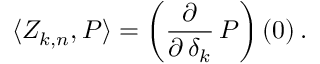<formula> <loc_0><loc_0><loc_500><loc_500>\langle Z _ { k , n } , P \rangle = \left ( { \frac { \partial } { \partial \, \delta _ { k } } } \, P \right ) ( 0 ) \, .</formula> 